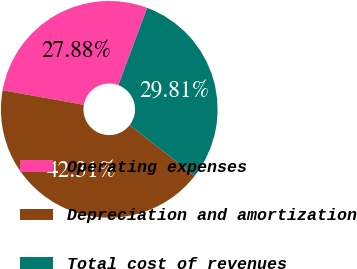Convert chart to OTSL. <chart><loc_0><loc_0><loc_500><loc_500><pie_chart><fcel>Operating expenses<fcel>Depreciation and amortization<fcel>Total cost of revenues<nl><fcel>27.88%<fcel>42.31%<fcel>29.81%<nl></chart> 